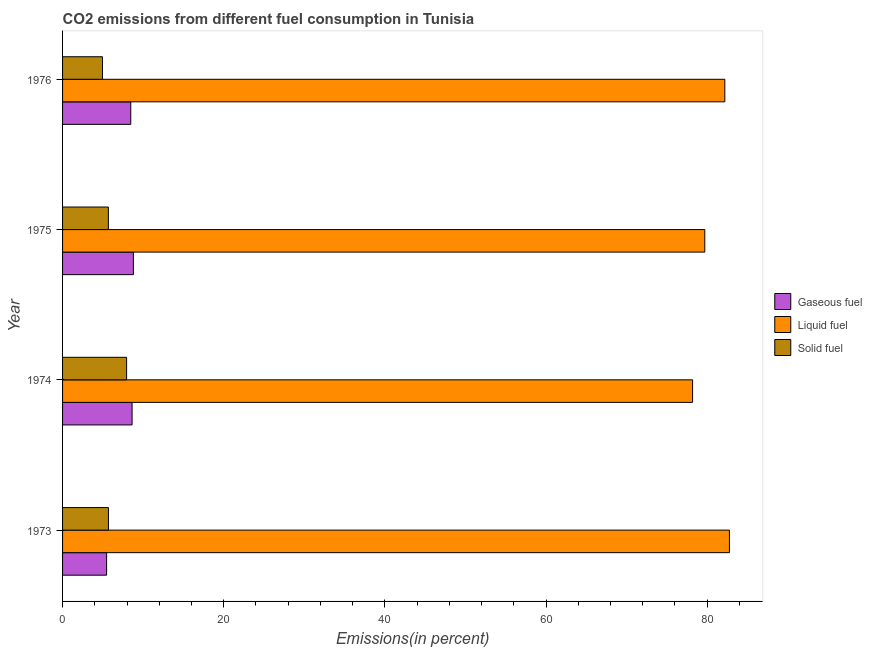How many different coloured bars are there?
Your answer should be compact. 3. What is the label of the 3rd group of bars from the top?
Give a very brief answer. 1974. What is the percentage of liquid fuel emission in 1973?
Give a very brief answer. 82.76. Across all years, what is the maximum percentage of gaseous fuel emission?
Offer a terse response. 8.79. Across all years, what is the minimum percentage of solid fuel emission?
Provide a succinct answer. 4.95. In which year was the percentage of liquid fuel emission maximum?
Offer a terse response. 1973. In which year was the percentage of solid fuel emission minimum?
Keep it short and to the point. 1976. What is the total percentage of gaseous fuel emission in the graph?
Provide a short and direct response. 31.35. What is the difference between the percentage of liquid fuel emission in 1973 and that in 1975?
Your answer should be very brief. 3.06. What is the difference between the percentage of liquid fuel emission in 1975 and the percentage of gaseous fuel emission in 1973?
Ensure brevity in your answer.  74.24. What is the average percentage of gaseous fuel emission per year?
Ensure brevity in your answer.  7.84. In the year 1976, what is the difference between the percentage of liquid fuel emission and percentage of gaseous fuel emission?
Your answer should be very brief. 73.73. What is the ratio of the percentage of gaseous fuel emission in 1973 to that in 1974?
Ensure brevity in your answer.  0.63. Is the percentage of solid fuel emission in 1973 less than that in 1976?
Your answer should be compact. No. What is the difference between the highest and the second highest percentage of liquid fuel emission?
Provide a succinct answer. 0.57. What is the difference between the highest and the lowest percentage of liquid fuel emission?
Ensure brevity in your answer.  4.57. What does the 2nd bar from the top in 1976 represents?
Offer a terse response. Liquid fuel. What does the 2nd bar from the bottom in 1974 represents?
Offer a very short reply. Liquid fuel. How many bars are there?
Provide a succinct answer. 12. What is the difference between two consecutive major ticks on the X-axis?
Make the answer very short. 20. Does the graph contain any zero values?
Keep it short and to the point. No. What is the title of the graph?
Ensure brevity in your answer.  CO2 emissions from different fuel consumption in Tunisia. Does "Social Insurance" appear as one of the legend labels in the graph?
Provide a succinct answer. No. What is the label or title of the X-axis?
Ensure brevity in your answer.  Emissions(in percent). What is the Emissions(in percent) in Gaseous fuel in 1973?
Ensure brevity in your answer.  5.47. What is the Emissions(in percent) in Liquid fuel in 1973?
Offer a very short reply. 82.76. What is the Emissions(in percent) of Solid fuel in 1973?
Offer a very short reply. 5.69. What is the Emissions(in percent) in Gaseous fuel in 1974?
Provide a short and direct response. 8.63. What is the Emissions(in percent) of Liquid fuel in 1974?
Provide a succinct answer. 78.19. What is the Emissions(in percent) in Solid fuel in 1974?
Your answer should be compact. 7.95. What is the Emissions(in percent) of Gaseous fuel in 1975?
Make the answer very short. 8.79. What is the Emissions(in percent) in Liquid fuel in 1975?
Offer a terse response. 79.71. What is the Emissions(in percent) in Solid fuel in 1975?
Provide a succinct answer. 5.68. What is the Emissions(in percent) in Gaseous fuel in 1976?
Your response must be concise. 8.46. What is the Emissions(in percent) in Liquid fuel in 1976?
Your response must be concise. 82.19. What is the Emissions(in percent) in Solid fuel in 1976?
Make the answer very short. 4.95. Across all years, what is the maximum Emissions(in percent) of Gaseous fuel?
Offer a very short reply. 8.79. Across all years, what is the maximum Emissions(in percent) of Liquid fuel?
Your response must be concise. 82.76. Across all years, what is the maximum Emissions(in percent) in Solid fuel?
Give a very brief answer. 7.95. Across all years, what is the minimum Emissions(in percent) of Gaseous fuel?
Your answer should be compact. 5.47. Across all years, what is the minimum Emissions(in percent) in Liquid fuel?
Your response must be concise. 78.19. Across all years, what is the minimum Emissions(in percent) of Solid fuel?
Offer a very short reply. 4.95. What is the total Emissions(in percent) of Gaseous fuel in the graph?
Make the answer very short. 31.35. What is the total Emissions(in percent) in Liquid fuel in the graph?
Provide a short and direct response. 322.86. What is the total Emissions(in percent) in Solid fuel in the graph?
Your response must be concise. 24.28. What is the difference between the Emissions(in percent) in Gaseous fuel in 1973 and that in 1974?
Ensure brevity in your answer.  -3.16. What is the difference between the Emissions(in percent) in Liquid fuel in 1973 and that in 1974?
Provide a short and direct response. 4.57. What is the difference between the Emissions(in percent) in Solid fuel in 1973 and that in 1974?
Keep it short and to the point. -2.25. What is the difference between the Emissions(in percent) in Gaseous fuel in 1973 and that in 1975?
Your answer should be compact. -3.32. What is the difference between the Emissions(in percent) in Liquid fuel in 1973 and that in 1975?
Your response must be concise. 3.05. What is the difference between the Emissions(in percent) of Solid fuel in 1973 and that in 1975?
Provide a succinct answer. 0.01. What is the difference between the Emissions(in percent) of Gaseous fuel in 1973 and that in 1976?
Ensure brevity in your answer.  -3. What is the difference between the Emissions(in percent) of Liquid fuel in 1973 and that in 1976?
Ensure brevity in your answer.  0.57. What is the difference between the Emissions(in percent) in Solid fuel in 1973 and that in 1976?
Keep it short and to the point. 0.74. What is the difference between the Emissions(in percent) in Gaseous fuel in 1974 and that in 1975?
Provide a short and direct response. -0.16. What is the difference between the Emissions(in percent) in Liquid fuel in 1974 and that in 1975?
Offer a terse response. -1.52. What is the difference between the Emissions(in percent) in Solid fuel in 1974 and that in 1975?
Make the answer very short. 2.26. What is the difference between the Emissions(in percent) in Gaseous fuel in 1974 and that in 1976?
Give a very brief answer. 0.16. What is the difference between the Emissions(in percent) in Liquid fuel in 1974 and that in 1976?
Your answer should be compact. -4. What is the difference between the Emissions(in percent) in Solid fuel in 1974 and that in 1976?
Offer a very short reply. 3. What is the difference between the Emissions(in percent) in Gaseous fuel in 1975 and that in 1976?
Keep it short and to the point. 0.33. What is the difference between the Emissions(in percent) of Liquid fuel in 1975 and that in 1976?
Offer a terse response. -2.49. What is the difference between the Emissions(in percent) of Solid fuel in 1975 and that in 1976?
Keep it short and to the point. 0.73. What is the difference between the Emissions(in percent) of Gaseous fuel in 1973 and the Emissions(in percent) of Liquid fuel in 1974?
Provide a short and direct response. -72.73. What is the difference between the Emissions(in percent) of Gaseous fuel in 1973 and the Emissions(in percent) of Solid fuel in 1974?
Give a very brief answer. -2.48. What is the difference between the Emissions(in percent) in Liquid fuel in 1973 and the Emissions(in percent) in Solid fuel in 1974?
Offer a very short reply. 74.82. What is the difference between the Emissions(in percent) in Gaseous fuel in 1973 and the Emissions(in percent) in Liquid fuel in 1975?
Give a very brief answer. -74.24. What is the difference between the Emissions(in percent) of Gaseous fuel in 1973 and the Emissions(in percent) of Solid fuel in 1975?
Offer a terse response. -0.22. What is the difference between the Emissions(in percent) in Liquid fuel in 1973 and the Emissions(in percent) in Solid fuel in 1975?
Offer a terse response. 77.08. What is the difference between the Emissions(in percent) in Gaseous fuel in 1973 and the Emissions(in percent) in Liquid fuel in 1976?
Make the answer very short. -76.73. What is the difference between the Emissions(in percent) of Gaseous fuel in 1973 and the Emissions(in percent) of Solid fuel in 1976?
Provide a succinct answer. 0.51. What is the difference between the Emissions(in percent) in Liquid fuel in 1973 and the Emissions(in percent) in Solid fuel in 1976?
Make the answer very short. 77.81. What is the difference between the Emissions(in percent) of Gaseous fuel in 1974 and the Emissions(in percent) of Liquid fuel in 1975?
Keep it short and to the point. -71.08. What is the difference between the Emissions(in percent) in Gaseous fuel in 1974 and the Emissions(in percent) in Solid fuel in 1975?
Your response must be concise. 2.94. What is the difference between the Emissions(in percent) in Liquid fuel in 1974 and the Emissions(in percent) in Solid fuel in 1975?
Ensure brevity in your answer.  72.51. What is the difference between the Emissions(in percent) of Gaseous fuel in 1974 and the Emissions(in percent) of Liquid fuel in 1976?
Provide a succinct answer. -73.57. What is the difference between the Emissions(in percent) in Gaseous fuel in 1974 and the Emissions(in percent) in Solid fuel in 1976?
Provide a succinct answer. 3.67. What is the difference between the Emissions(in percent) in Liquid fuel in 1974 and the Emissions(in percent) in Solid fuel in 1976?
Provide a succinct answer. 73.24. What is the difference between the Emissions(in percent) in Gaseous fuel in 1975 and the Emissions(in percent) in Liquid fuel in 1976?
Give a very brief answer. -73.4. What is the difference between the Emissions(in percent) in Gaseous fuel in 1975 and the Emissions(in percent) in Solid fuel in 1976?
Give a very brief answer. 3.84. What is the difference between the Emissions(in percent) of Liquid fuel in 1975 and the Emissions(in percent) of Solid fuel in 1976?
Your response must be concise. 74.76. What is the average Emissions(in percent) in Gaseous fuel per year?
Your answer should be compact. 7.84. What is the average Emissions(in percent) of Liquid fuel per year?
Ensure brevity in your answer.  80.72. What is the average Emissions(in percent) of Solid fuel per year?
Your answer should be very brief. 6.07. In the year 1973, what is the difference between the Emissions(in percent) of Gaseous fuel and Emissions(in percent) of Liquid fuel?
Your answer should be very brief. -77.3. In the year 1973, what is the difference between the Emissions(in percent) of Gaseous fuel and Emissions(in percent) of Solid fuel?
Your response must be concise. -0.23. In the year 1973, what is the difference between the Emissions(in percent) in Liquid fuel and Emissions(in percent) in Solid fuel?
Your answer should be compact. 77.07. In the year 1974, what is the difference between the Emissions(in percent) in Gaseous fuel and Emissions(in percent) in Liquid fuel?
Provide a short and direct response. -69.57. In the year 1974, what is the difference between the Emissions(in percent) in Gaseous fuel and Emissions(in percent) in Solid fuel?
Provide a succinct answer. 0.68. In the year 1974, what is the difference between the Emissions(in percent) in Liquid fuel and Emissions(in percent) in Solid fuel?
Ensure brevity in your answer.  70.24. In the year 1975, what is the difference between the Emissions(in percent) in Gaseous fuel and Emissions(in percent) in Liquid fuel?
Your response must be concise. -70.92. In the year 1975, what is the difference between the Emissions(in percent) of Gaseous fuel and Emissions(in percent) of Solid fuel?
Your answer should be very brief. 3.11. In the year 1975, what is the difference between the Emissions(in percent) in Liquid fuel and Emissions(in percent) in Solid fuel?
Give a very brief answer. 74.03. In the year 1976, what is the difference between the Emissions(in percent) in Gaseous fuel and Emissions(in percent) in Liquid fuel?
Offer a terse response. -73.73. In the year 1976, what is the difference between the Emissions(in percent) in Gaseous fuel and Emissions(in percent) in Solid fuel?
Your answer should be compact. 3.51. In the year 1976, what is the difference between the Emissions(in percent) of Liquid fuel and Emissions(in percent) of Solid fuel?
Keep it short and to the point. 77.24. What is the ratio of the Emissions(in percent) of Gaseous fuel in 1973 to that in 1974?
Offer a terse response. 0.63. What is the ratio of the Emissions(in percent) in Liquid fuel in 1973 to that in 1974?
Ensure brevity in your answer.  1.06. What is the ratio of the Emissions(in percent) of Solid fuel in 1973 to that in 1974?
Your answer should be very brief. 0.72. What is the ratio of the Emissions(in percent) in Gaseous fuel in 1973 to that in 1975?
Your answer should be very brief. 0.62. What is the ratio of the Emissions(in percent) in Liquid fuel in 1973 to that in 1975?
Give a very brief answer. 1.04. What is the ratio of the Emissions(in percent) in Solid fuel in 1973 to that in 1975?
Offer a terse response. 1. What is the ratio of the Emissions(in percent) of Gaseous fuel in 1973 to that in 1976?
Your answer should be compact. 0.65. What is the ratio of the Emissions(in percent) of Solid fuel in 1973 to that in 1976?
Ensure brevity in your answer.  1.15. What is the ratio of the Emissions(in percent) of Gaseous fuel in 1974 to that in 1975?
Ensure brevity in your answer.  0.98. What is the ratio of the Emissions(in percent) in Solid fuel in 1974 to that in 1975?
Give a very brief answer. 1.4. What is the ratio of the Emissions(in percent) of Gaseous fuel in 1974 to that in 1976?
Give a very brief answer. 1.02. What is the ratio of the Emissions(in percent) of Liquid fuel in 1974 to that in 1976?
Ensure brevity in your answer.  0.95. What is the ratio of the Emissions(in percent) in Solid fuel in 1974 to that in 1976?
Make the answer very short. 1.6. What is the ratio of the Emissions(in percent) of Gaseous fuel in 1975 to that in 1976?
Offer a terse response. 1.04. What is the ratio of the Emissions(in percent) of Liquid fuel in 1975 to that in 1976?
Your answer should be compact. 0.97. What is the ratio of the Emissions(in percent) of Solid fuel in 1975 to that in 1976?
Offer a very short reply. 1.15. What is the difference between the highest and the second highest Emissions(in percent) of Gaseous fuel?
Ensure brevity in your answer.  0.16. What is the difference between the highest and the second highest Emissions(in percent) in Liquid fuel?
Provide a succinct answer. 0.57. What is the difference between the highest and the second highest Emissions(in percent) of Solid fuel?
Give a very brief answer. 2.25. What is the difference between the highest and the lowest Emissions(in percent) in Gaseous fuel?
Offer a very short reply. 3.32. What is the difference between the highest and the lowest Emissions(in percent) of Liquid fuel?
Your answer should be very brief. 4.57. What is the difference between the highest and the lowest Emissions(in percent) of Solid fuel?
Offer a terse response. 3. 